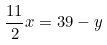Convert formula to latex. <formula><loc_0><loc_0><loc_500><loc_500>\frac { 1 1 } { 2 } x = 3 9 - y</formula> 